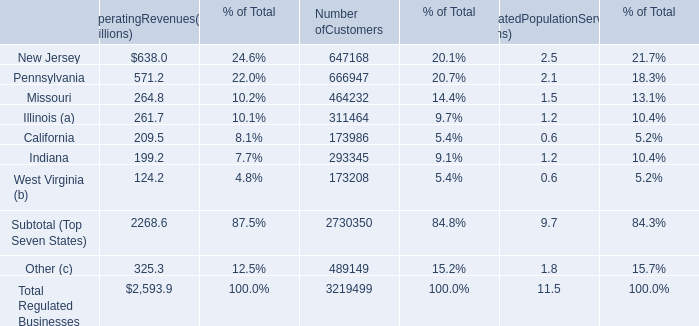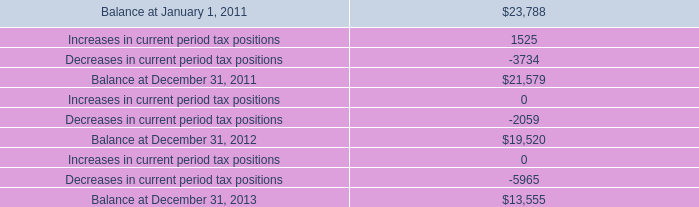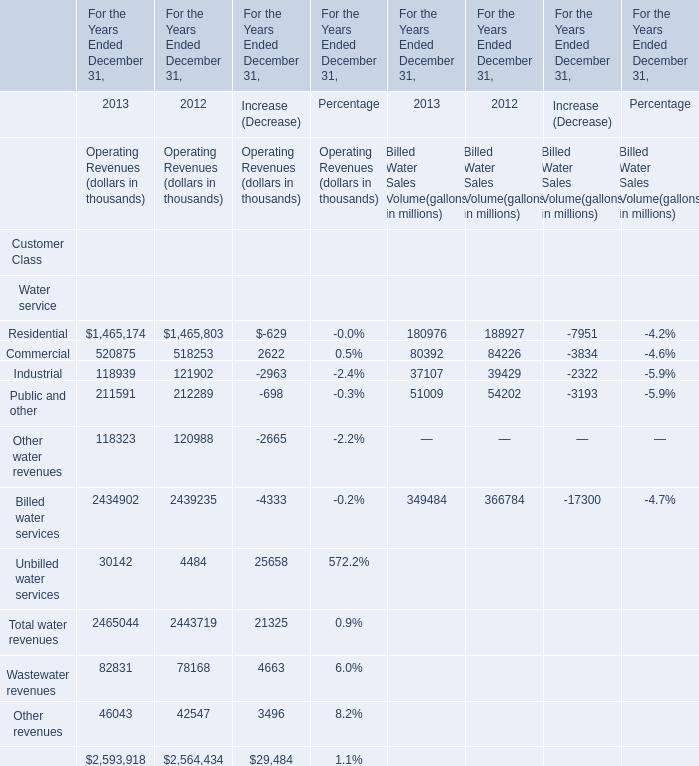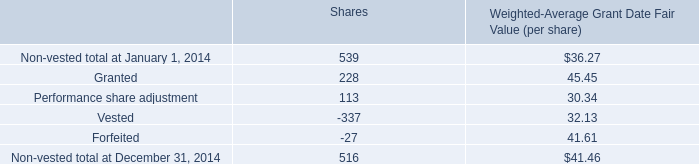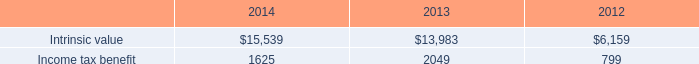What is the sum of Income tax benefit of 2014, Balance at December 31, 2012, and New Jersey of Number ofCustomers ? 
Computations: ((1625.0 + 19520.0) + 647168.0)
Answer: 668313.0. 